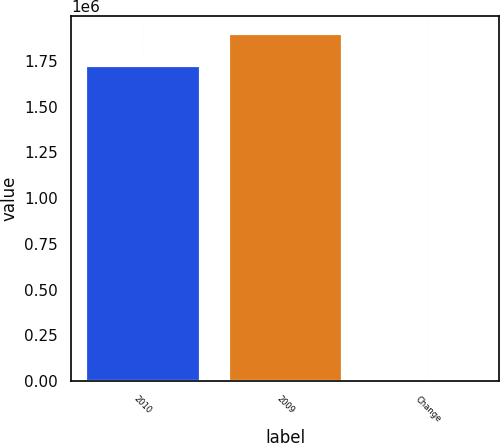Convert chart. <chart><loc_0><loc_0><loc_500><loc_500><bar_chart><fcel>2010<fcel>2009<fcel>Change<nl><fcel>1.72827e+06<fcel>1.90109e+06<fcel>2067<nl></chart> 